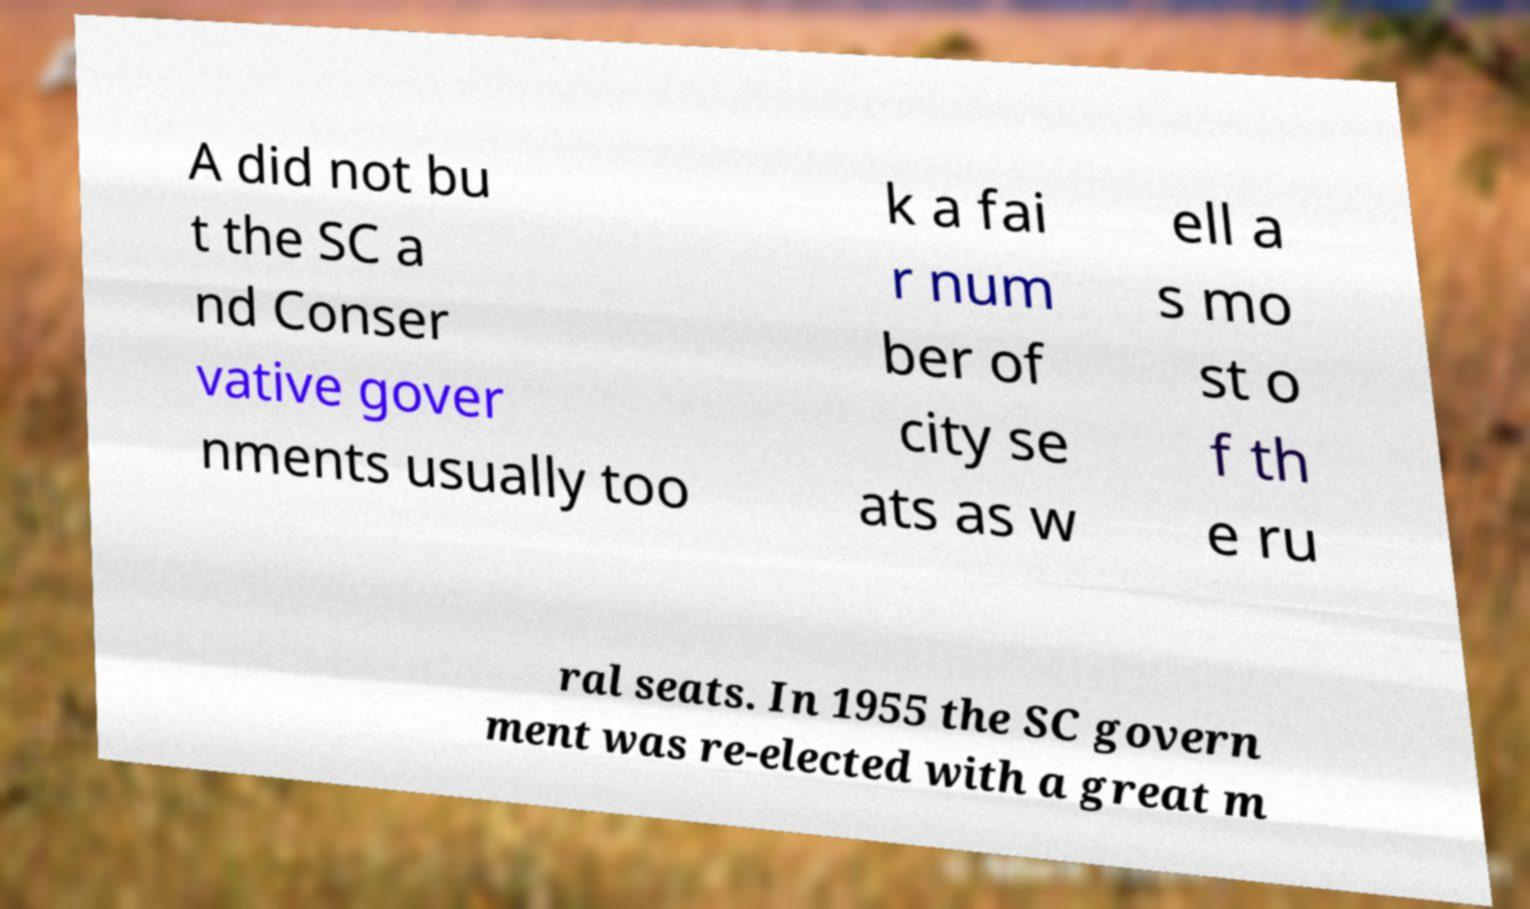There's text embedded in this image that I need extracted. Can you transcribe it verbatim? A did not bu t the SC a nd Conser vative gover nments usually too k a fai r num ber of city se ats as w ell a s mo st o f th e ru ral seats. In 1955 the SC govern ment was re-elected with a great m 